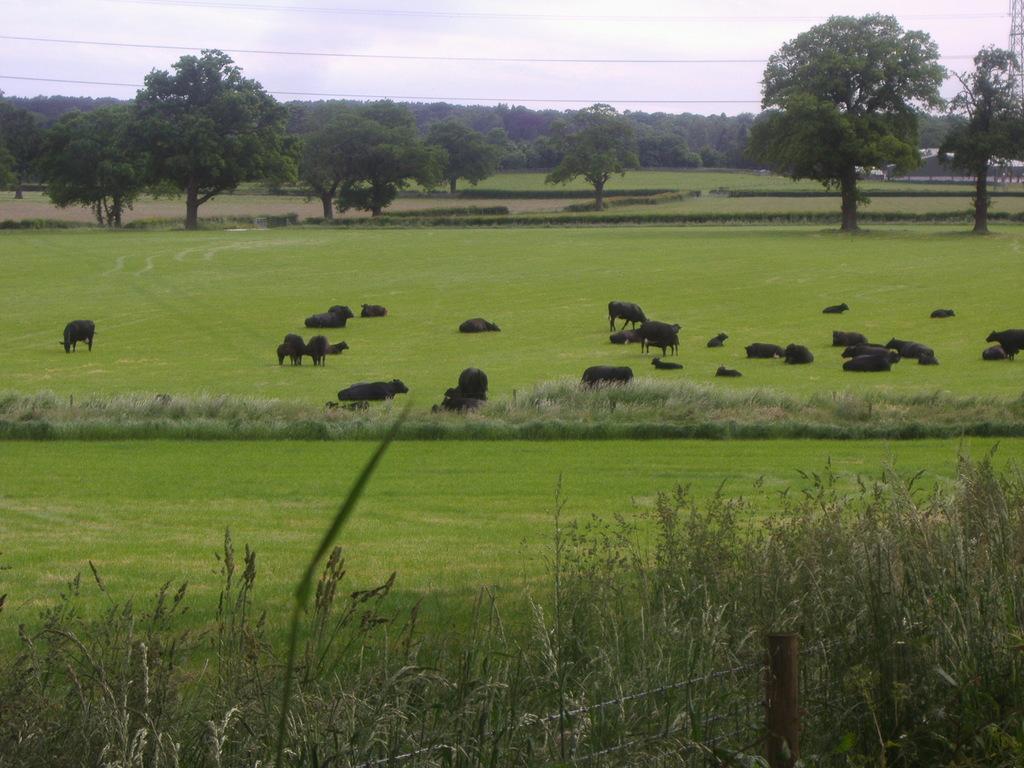How would you summarize this image in a sentence or two? In this image in the center there are some animals, and at the bottom there is grass and some plants. In the background there are some wires, and at the top there are some wires. On the right side there is tower, at the top of the image there is sky. 